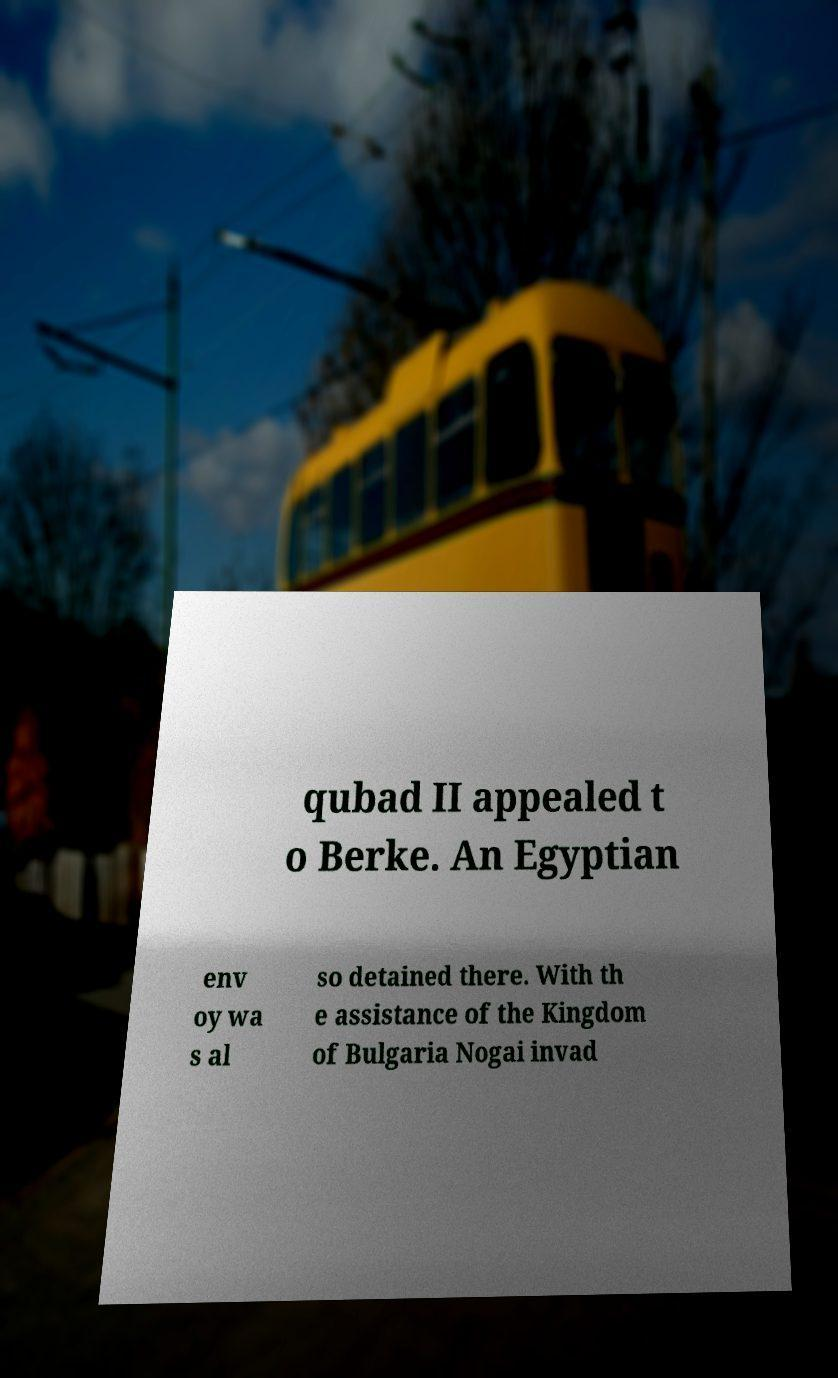I need the written content from this picture converted into text. Can you do that? qubad II appealed t o Berke. An Egyptian env oy wa s al so detained there. With th e assistance of the Kingdom of Bulgaria Nogai invad 